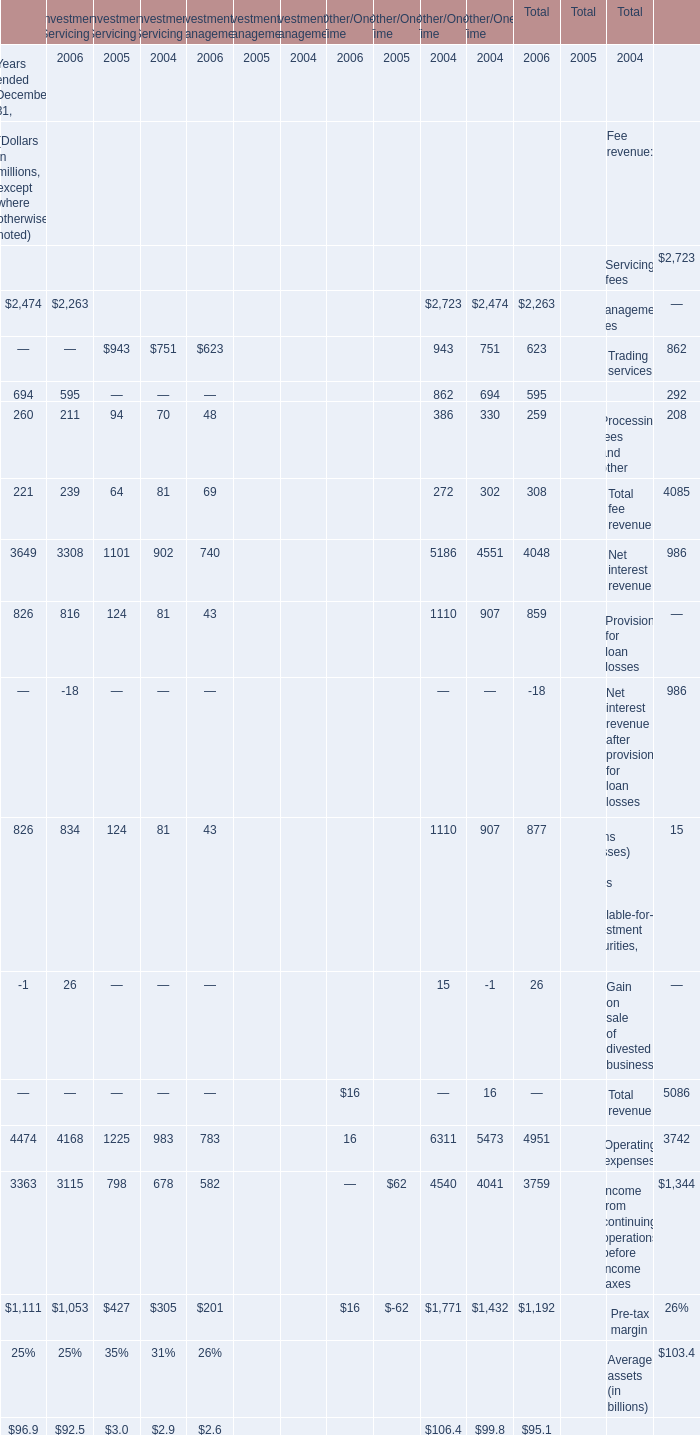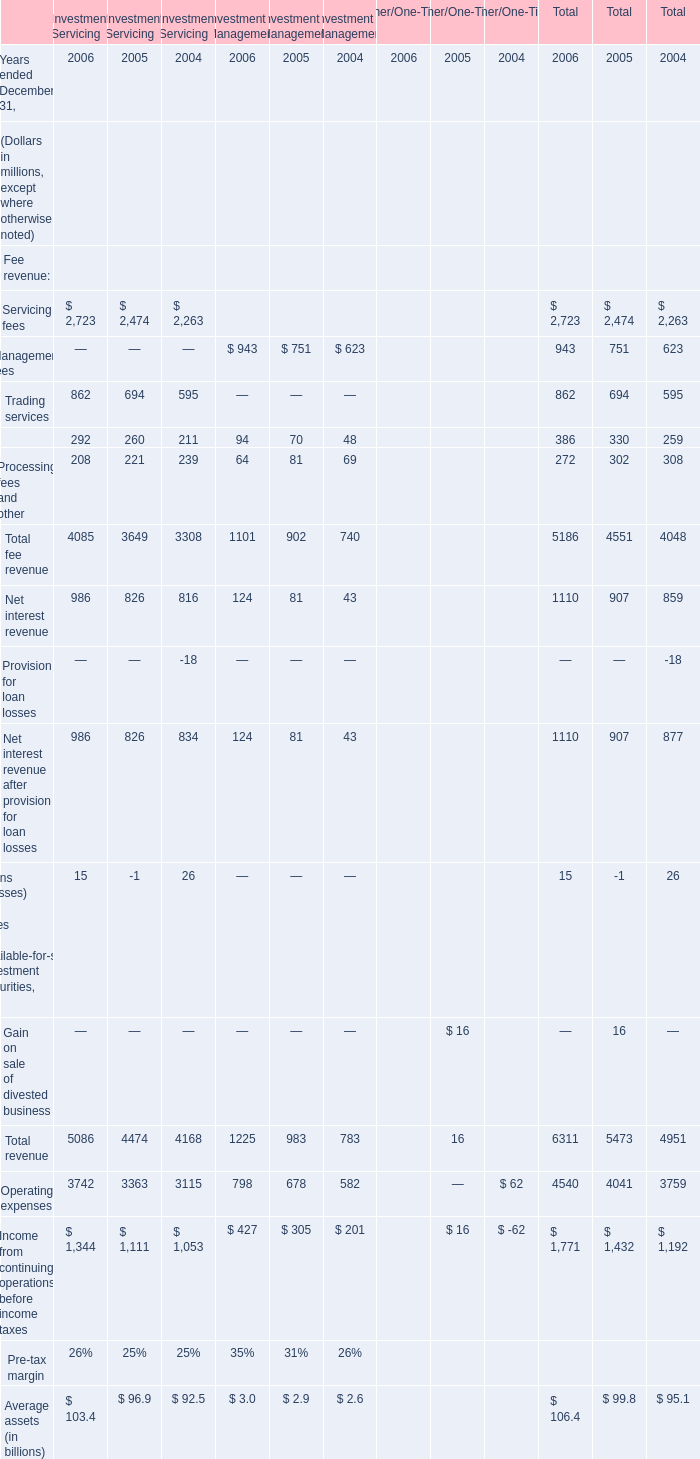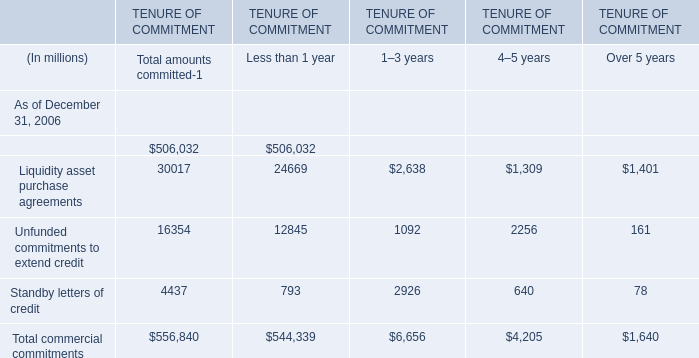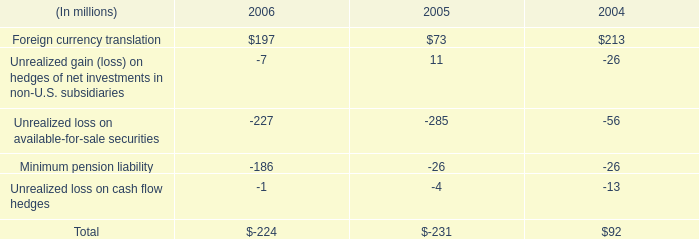What is the total value of Servicing fees, Trading services, Securities finance and Processing fees and other in 2006 of investment servicing ? (in million) 
Computations: (((2723 + 862) + 292) + 208)
Answer: 4085.0. 